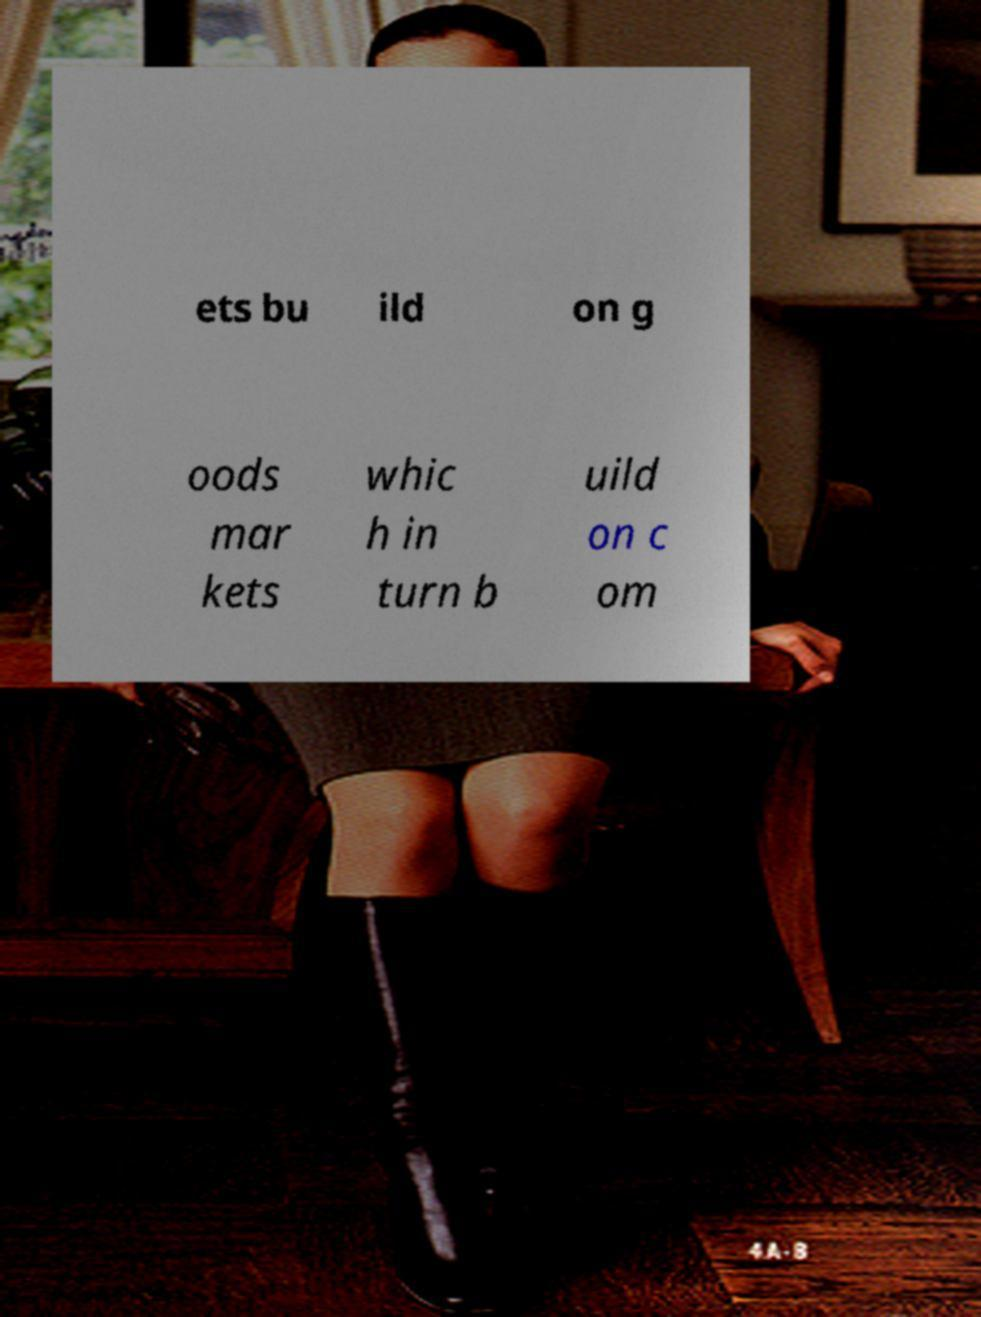There's text embedded in this image that I need extracted. Can you transcribe it verbatim? ets bu ild on g oods mar kets whic h in turn b uild on c om 